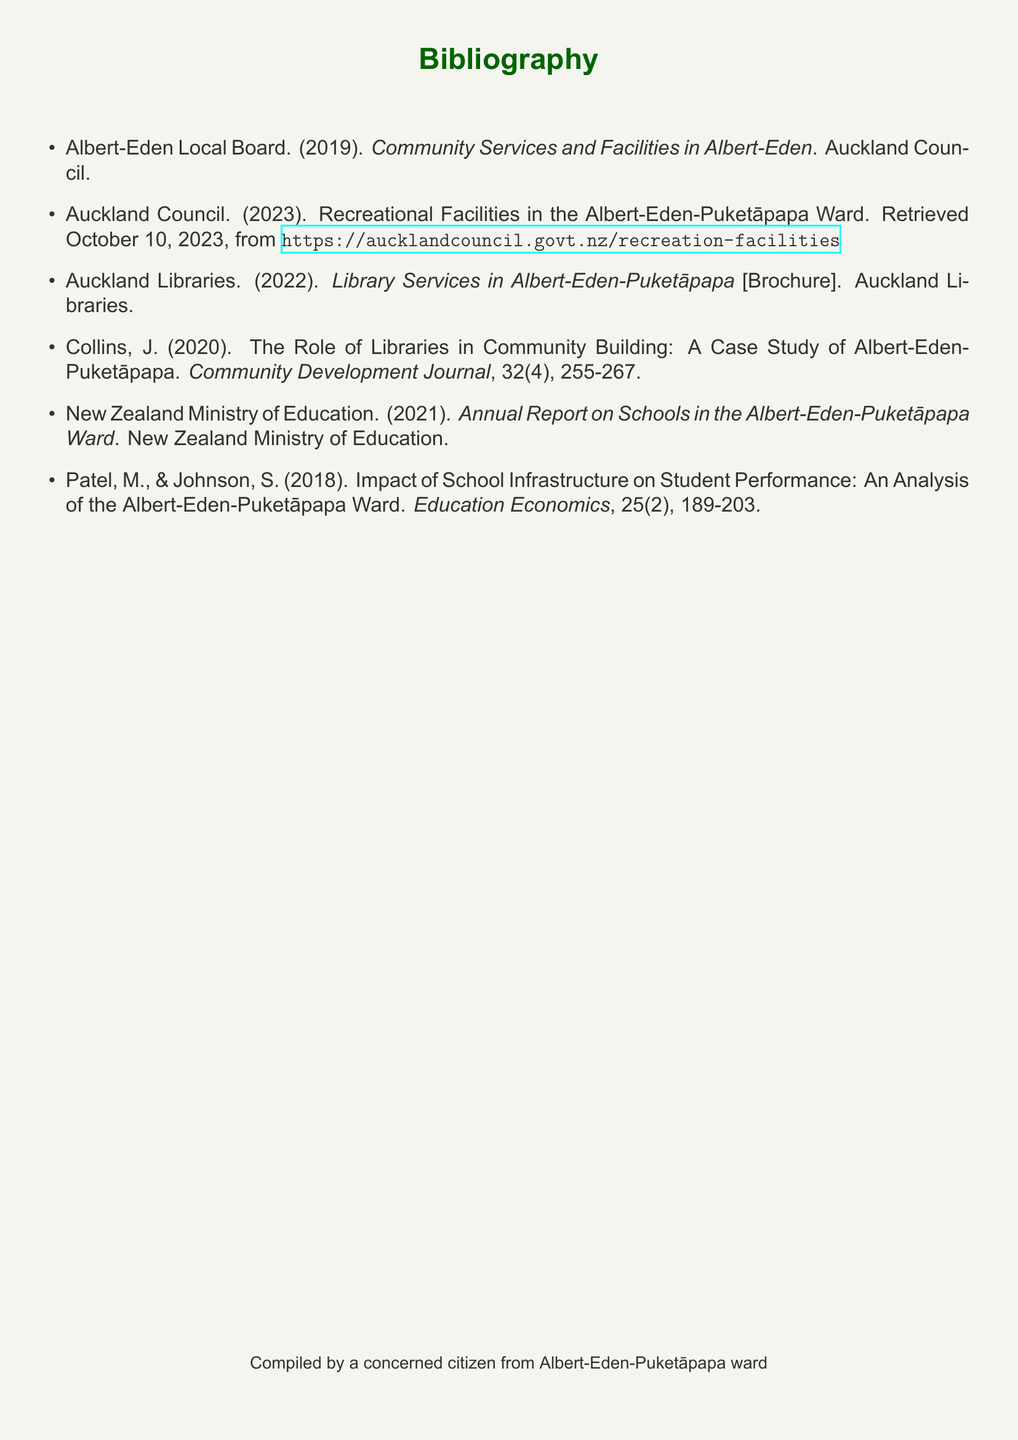what is the title of the publication by Albert-Eden Local Board? The title is found in the first item of the bibliography, which lists the publication's title.
Answer: Community Services and Facilities in Albert-Eden which organization published a brochure about library services? The bibliography indicates the publisher of the library services brochure.
Answer: Auckland Libraries what year was the annual report on schools published? The year can be found in the citation of the annual report on schools in the bibliography.
Answer: 2021 who authored the article on the impact of school infrastructure? The authors are listed in the citation for the article on school infrastructure in the bibliography.
Answer: Patel, M., & Johnson, S how many items are listed in the bibliography? The total number of items can be counted in the list provided.
Answer: 6 what is the publication year of the case study on libraries? The publication year is noted in the citation of the case study about libraries.
Answer: 2020 which council is responsible for recreational facilities in the ward? The citation regarding recreational facilities specifies the responsible council.
Answer: Auckland Council in which journal is the article about libraries published? The journal name can be found in the citation of the article about libraries.
Answer: Community Development Journal 